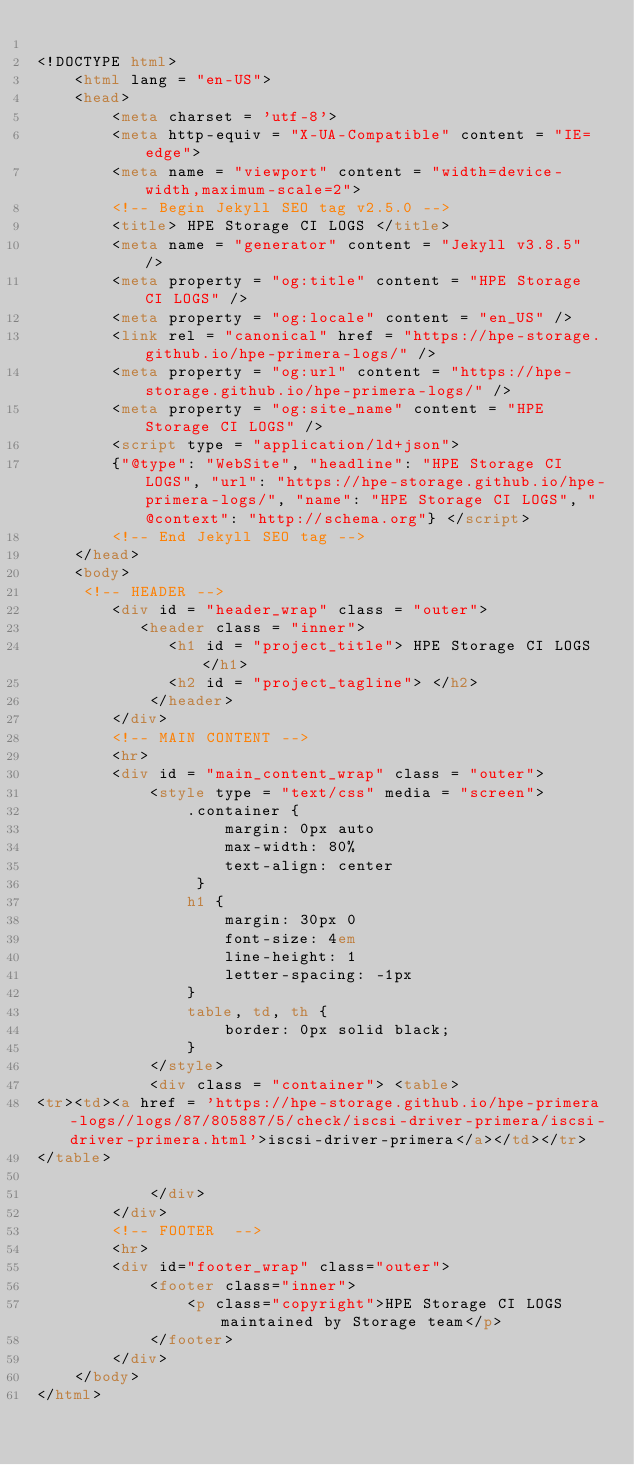<code> <loc_0><loc_0><loc_500><loc_500><_HTML_>
<!DOCTYPE html>
    <html lang = "en-US">
    <head>
        <meta charset = 'utf-8'>
        <meta http-equiv = "X-UA-Compatible" content = "IE=edge">
        <meta name = "viewport" content = "width=device-width,maximum-scale=2">
        <!-- Begin Jekyll SEO tag v2.5.0 -->
        <title> HPE Storage CI LOGS </title>
        <meta name = "generator" content = "Jekyll v3.8.5" />
        <meta property = "og:title" content = "HPE Storage CI LOGS" />
        <meta property = "og:locale" content = "en_US" />
        <link rel = "canonical" href = "https://hpe-storage.github.io/hpe-primera-logs/" />
        <meta property = "og:url" content = "https://hpe-storage.github.io/hpe-primera-logs/" />
        <meta property = "og:site_name" content = "HPE Storage CI LOGS" />
        <script type = "application/ld+json">
        {"@type": "WebSite", "headline": "HPE Storage CI LOGS", "url": "https://hpe-storage.github.io/hpe-primera-logs/", "name": "HPE Storage CI LOGS", "@context": "http://schema.org"} </script>
        <!-- End Jekyll SEO tag -->
    </head>
    <body>
     <!-- HEADER -->
        <div id = "header_wrap" class = "outer">
           <header class = "inner">
              <h1 id = "project_title"> HPE Storage CI LOGS </h1>
              <h2 id = "project_tagline"> </h2>
            </header>
        </div>
        <!-- MAIN CONTENT -->
        <hr>
        <div id = "main_content_wrap" class = "outer">
            <style type = "text/css" media = "screen">
                .container {
                    margin: 0px auto
                    max-width: 80%
                    text-align: center
                 }
                h1 {
                    margin: 30px 0
                    font-size: 4em
                    line-height: 1
                    letter-spacing: -1px
                }
                table, td, th {
                    border: 0px solid black;
                }
            </style>
            <div class = "container"> <table>
<tr><td><a href = 'https://hpe-storage.github.io/hpe-primera-logs//logs/87/805887/5/check/iscsi-driver-primera/iscsi-driver-primera.html'>iscsi-driver-primera</a></td></tr>
</table>

            </div>
        </div>
        <!-- FOOTER  -->
        <hr>
        <div id="footer_wrap" class="outer">
            <footer class="inner">
                <p class="copyright">HPE Storage CI LOGS maintained by Storage team</p>
            </footer>
        </div>
    </body>
</html>
</code> 